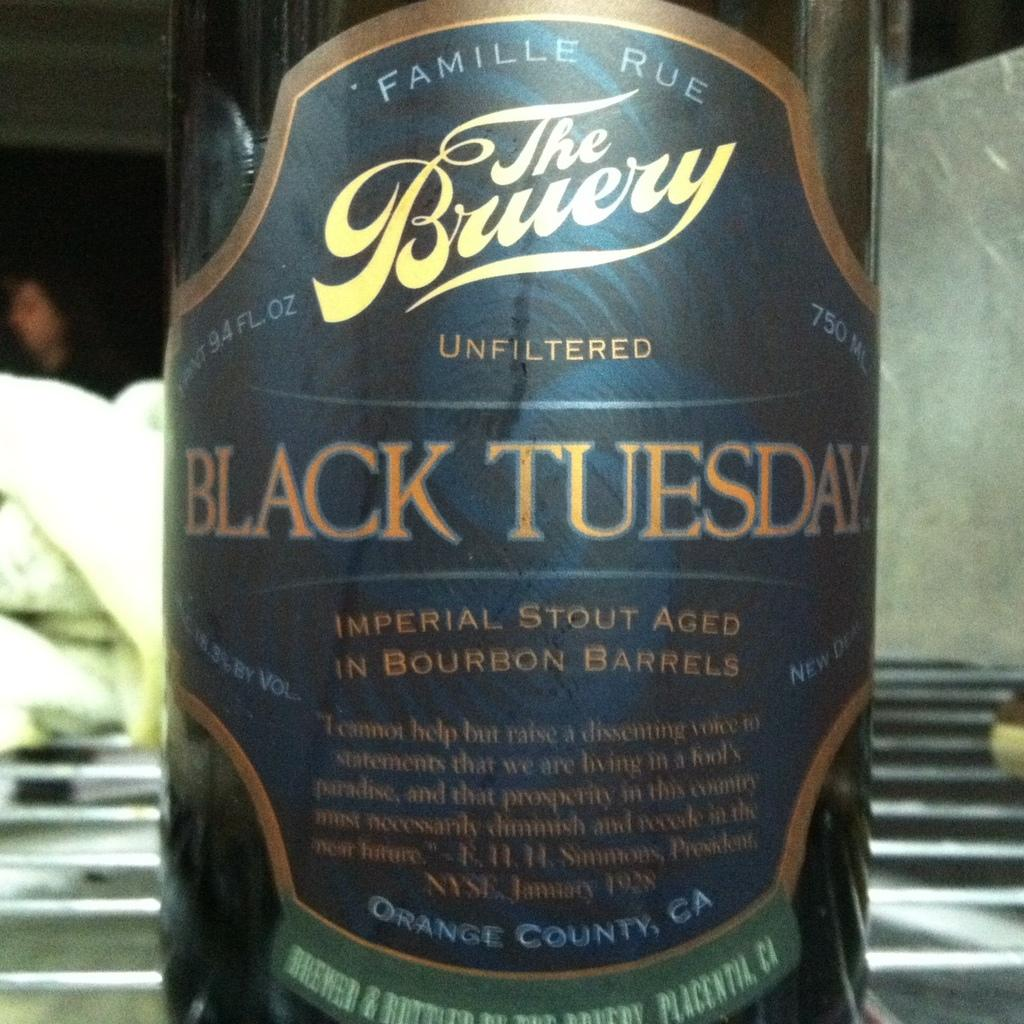<image>
Present a compact description of the photo's key features. A bottle of a stout with a label that says Black Tuesday. 